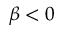Convert formula to latex. <formula><loc_0><loc_0><loc_500><loc_500>\beta < 0</formula> 